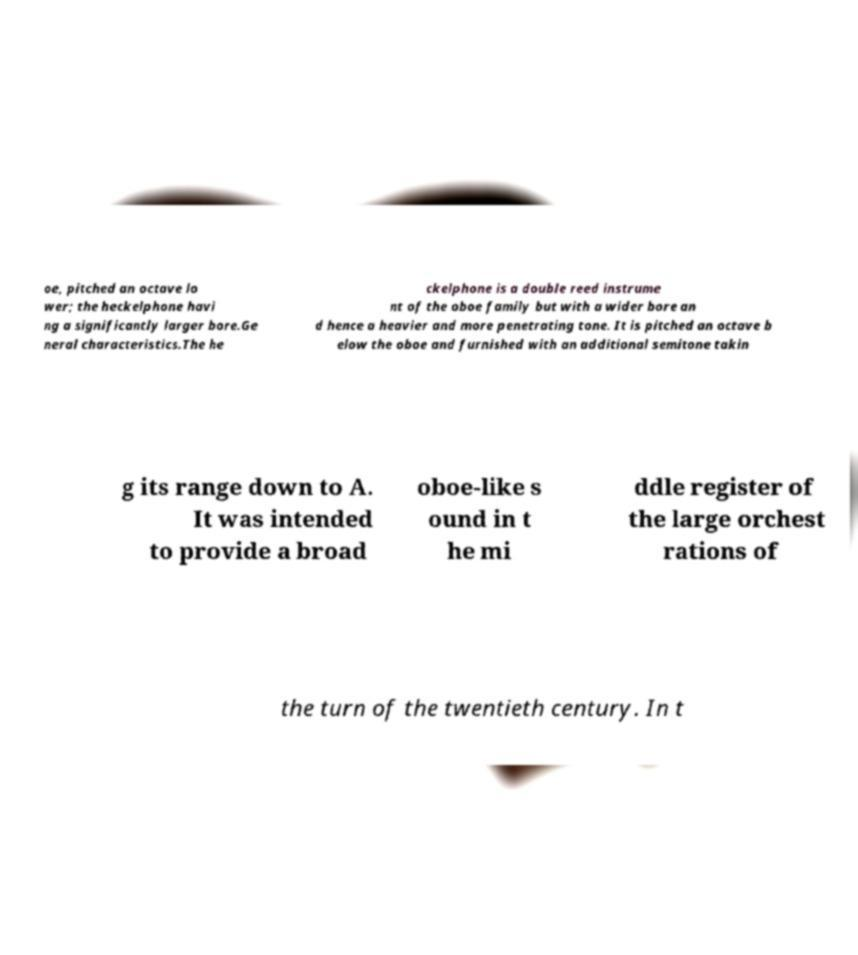Could you assist in decoding the text presented in this image and type it out clearly? oe, pitched an octave lo wer; the heckelphone havi ng a significantly larger bore.Ge neral characteristics.The he ckelphone is a double reed instrume nt of the oboe family but with a wider bore an d hence a heavier and more penetrating tone. It is pitched an octave b elow the oboe and furnished with an additional semitone takin g its range down to A. It was intended to provide a broad oboe-like s ound in t he mi ddle register of the large orchest rations of the turn of the twentieth century. In t 